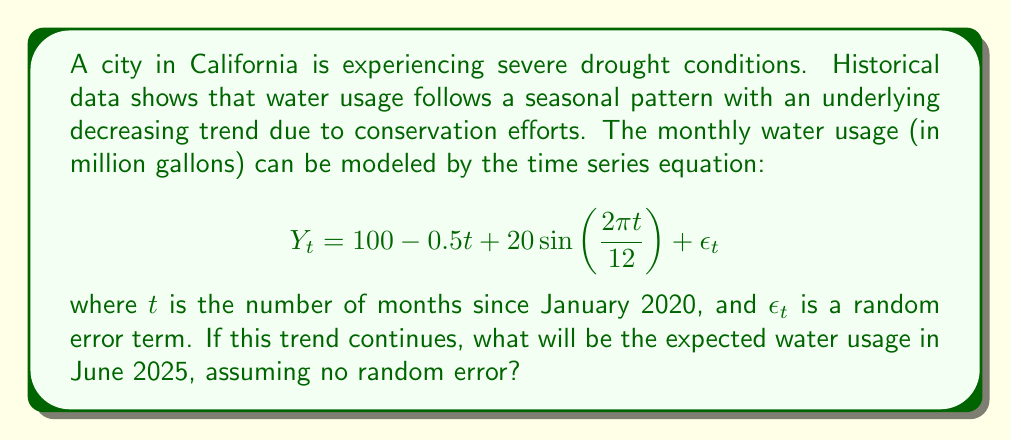Provide a solution to this math problem. To solve this problem, we need to follow these steps:

1. Identify the components of the time series equation:
   - Trend: $100 - 0.5t$
   - Seasonality: $20\sin(\frac{2\pi t}{12})$
   - Error term: $\epsilon_t$ (assumed to be 0 for this prediction)

2. Calculate the value of $t$ for June 2025:
   - January 2020 to June 2025 is 5 years and 5 months
   - $t = (5 \times 12) + 5 = 65$ months

3. Substitute $t = 65$ into the equation:
   $$Y_{65} = 100 - 0.5(65) + 20\sin(\frac{2\pi (65)}{12})$$

4. Calculate the trend component:
   $100 - 0.5(65) = 100 - 32.5 = 67.5$

5. Calculate the seasonal component:
   $20\sin(\frac{2\pi (65)}{12}) = 20\sin(\frac{130\pi}{12}) \approx 20\sin(10.8333\pi) \approx 0$

6. Sum the components:
   $Y_{65} = 67.5 + 0 = 67.5$

Therefore, the expected water usage in June 2025 is approximately 67.5 million gallons.
Answer: 67.5 million gallons 